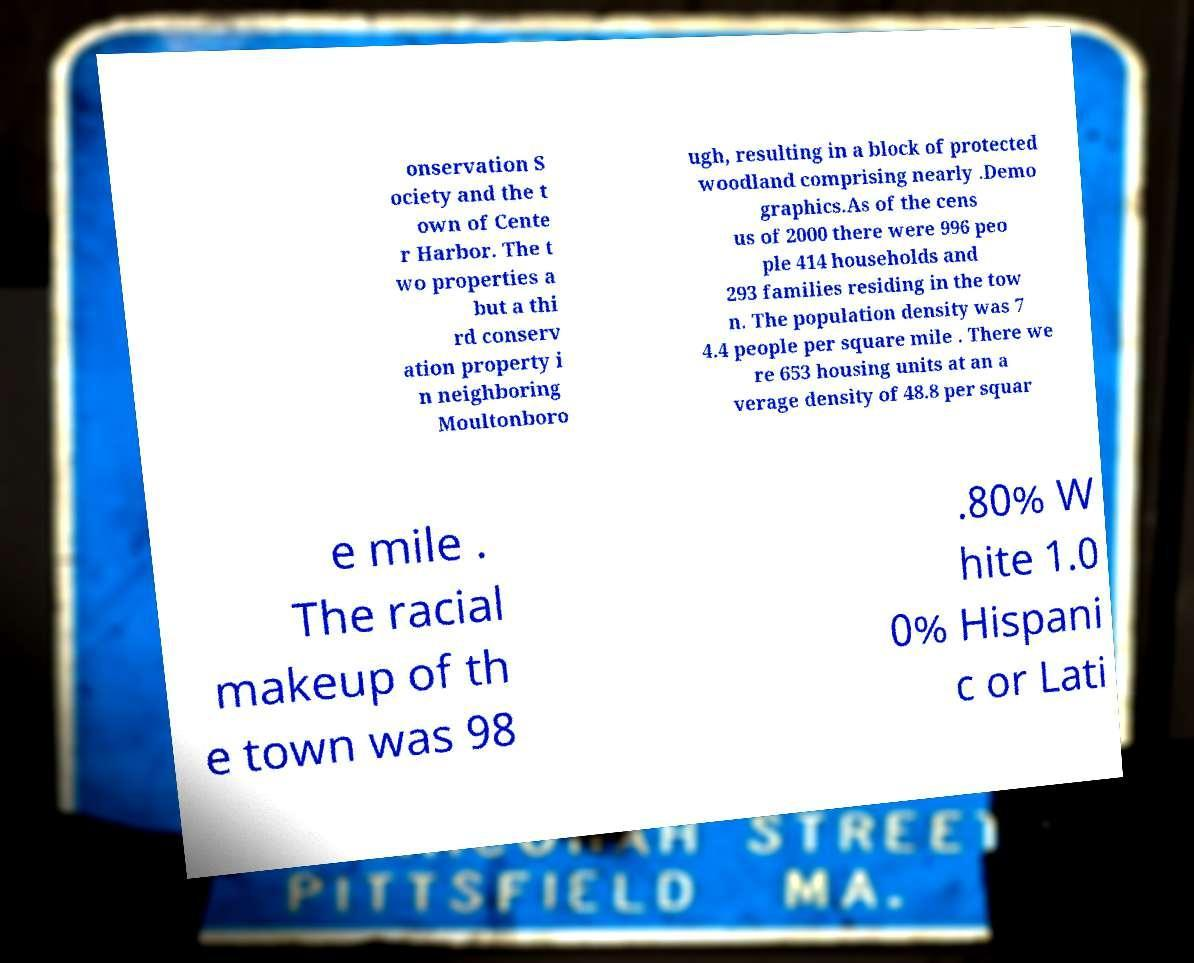What messages or text are displayed in this image? I need them in a readable, typed format. onservation S ociety and the t own of Cente r Harbor. The t wo properties a but a thi rd conserv ation property i n neighboring Moultonboro ugh, resulting in a block of protected woodland comprising nearly .Demo graphics.As of the cens us of 2000 there were 996 peo ple 414 households and 293 families residing in the tow n. The population density was 7 4.4 people per square mile . There we re 653 housing units at an a verage density of 48.8 per squar e mile . The racial makeup of th e town was 98 .80% W hite 1.0 0% Hispani c or Lati 